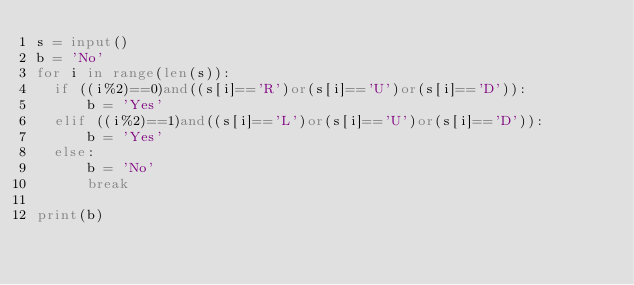<code> <loc_0><loc_0><loc_500><loc_500><_Python_>s = input()
b = 'No'
for i in range(len(s)):
  if ((i%2)==0)and((s[i]=='R')or(s[i]=='U')or(s[i]=='D')):
      b = 'Yes'
  elif ((i%2)==1)and((s[i]=='L')or(s[i]=='U')or(s[i]=='D')):
      b = 'Yes'
  else:
      b = 'No'
      break

print(b)</code> 